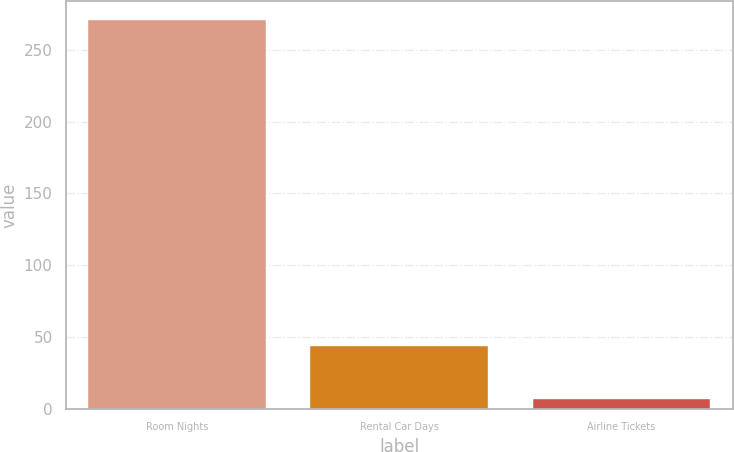<chart> <loc_0><loc_0><loc_500><loc_500><bar_chart><fcel>Room Nights<fcel>Rental Car Days<fcel>Airline Tickets<nl><fcel>270.5<fcel>43.9<fcel>7<nl></chart> 